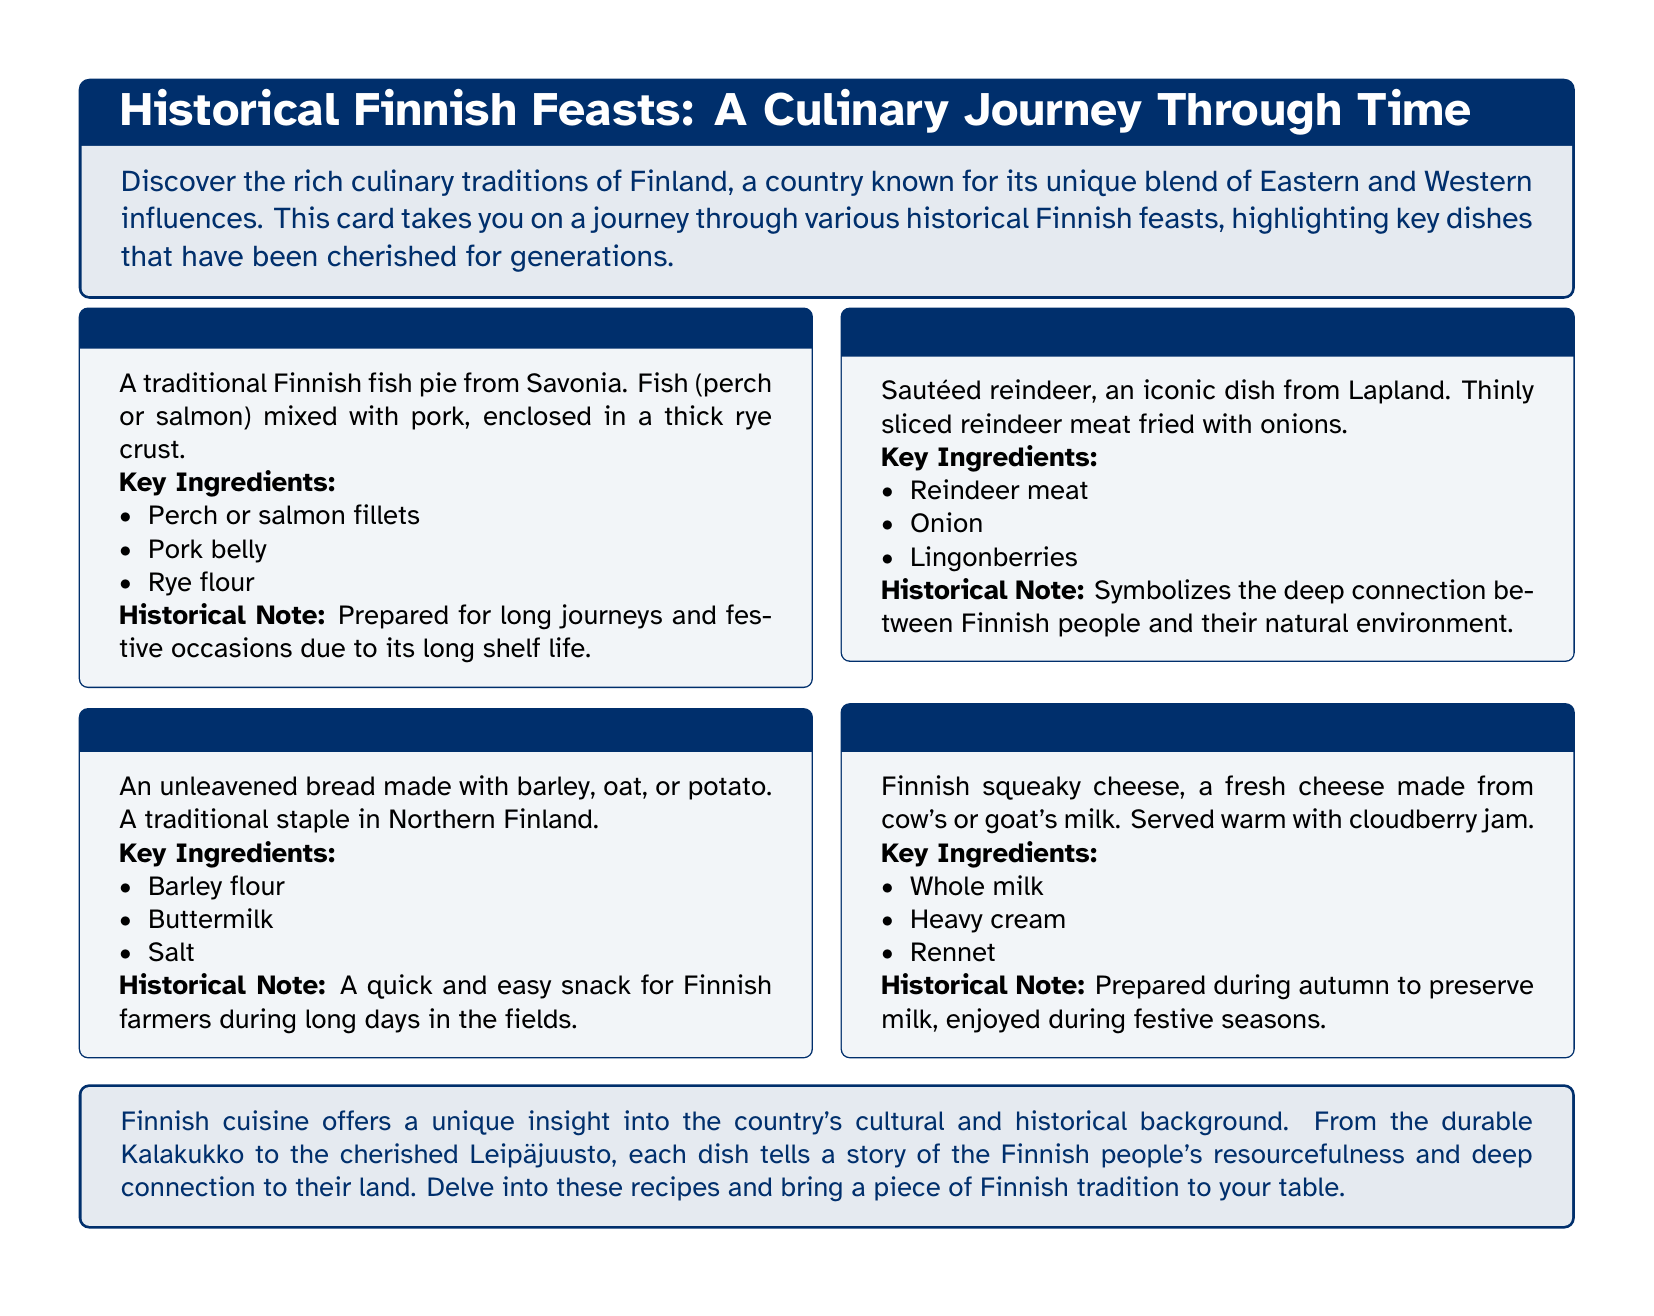What is Kalakukko? Kalakukko is described as a traditional Finnish fish pie from Savonia, made with fish mixed with pork and enclosed in a rye crust.
Answer: Traditional Finnish fish pie What are the key ingredients of Rieska? The key ingredients of Rieska include barley flour, buttermilk, and salt, as listed in the recipe card.
Answer: Barley flour, buttermilk, salt Where does Poronkäristys originate from? Poronkäristys is noted as an iconic dish from Lapland in the document.
Answer: Lapland What is Leipäjuusto served with? According to the document, Leipäjuusto is served warm with cloudberry jam.
Answer: Cloudberry jam Why was Kalakukko prepared? The historical note states that Kalakukko was prepared for long journeys and festive occasions due to its long shelf life.
Answer: Long journeys and festive occasions What type of cheese is Leipäjuusto? The document states that Leipäjuusto is a fresh cheese made from cow's or goat's milk.
Answer: Fresh cheese How many main dishes are listed in the document? There are four main dishes described in the document: Kalakukko, Rieska, Poronkäristys, and Leipäjuusto, thus totaling to four.
Answer: Four What does Finnish cuisine offer insight into? The document mentions that Finnish cuisine offers a unique insight into the country's cultural and historical background.
Answer: Cultural and historical background 